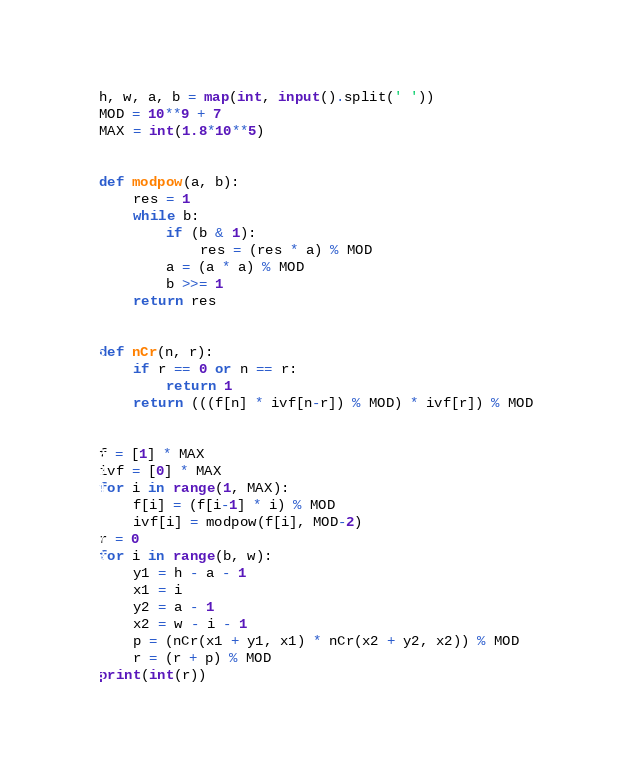Convert code to text. <code><loc_0><loc_0><loc_500><loc_500><_Python_>h, w, a, b = map(int, input().split(' '))
MOD = 10**9 + 7
MAX = int(1.8*10**5)


def modpow(a, b):
    res = 1
    while b:
        if (b & 1):
            res = (res * a) % MOD
        a = (a * a) % MOD
        b >>= 1
    return res


def nCr(n, r):
    if r == 0 or n == r:
        return 1
    return (((f[n] * ivf[n-r]) % MOD) * ivf[r]) % MOD


f = [1] * MAX
ivf = [0] * MAX
for i in range(1, MAX):
    f[i] = (f[i-1] * i) % MOD
    ivf[i] = modpow(f[i], MOD-2)
r = 0
for i in range(b, w):
    y1 = h - a - 1
    x1 = i
    y2 = a - 1
    x2 = w - i - 1
    p = (nCr(x1 + y1, x1) * nCr(x2 + y2, x2)) % MOD
    r = (r + p) % MOD
print(int(r))
</code> 